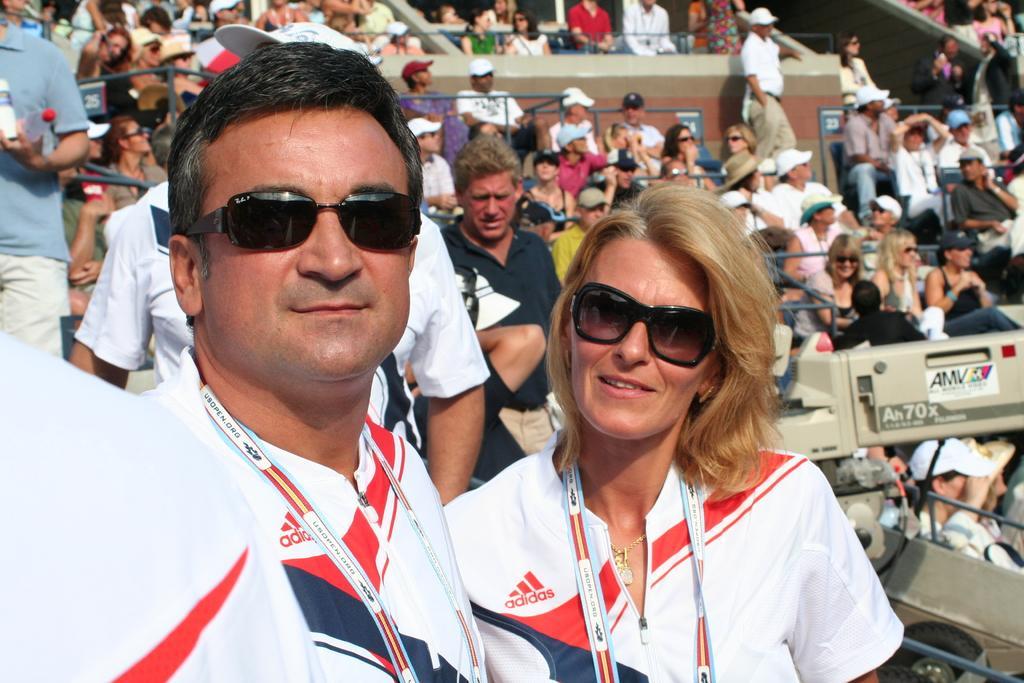Can you describe this image briefly? In this image we can see some people are sitting, some people are standing, one poster with text attached to one object, small boards with numbers, some objects on the ground, some people are holding some objects, some people are walking, some people are truncated and two people in white dress in the middle of the image wearing ID cards. 